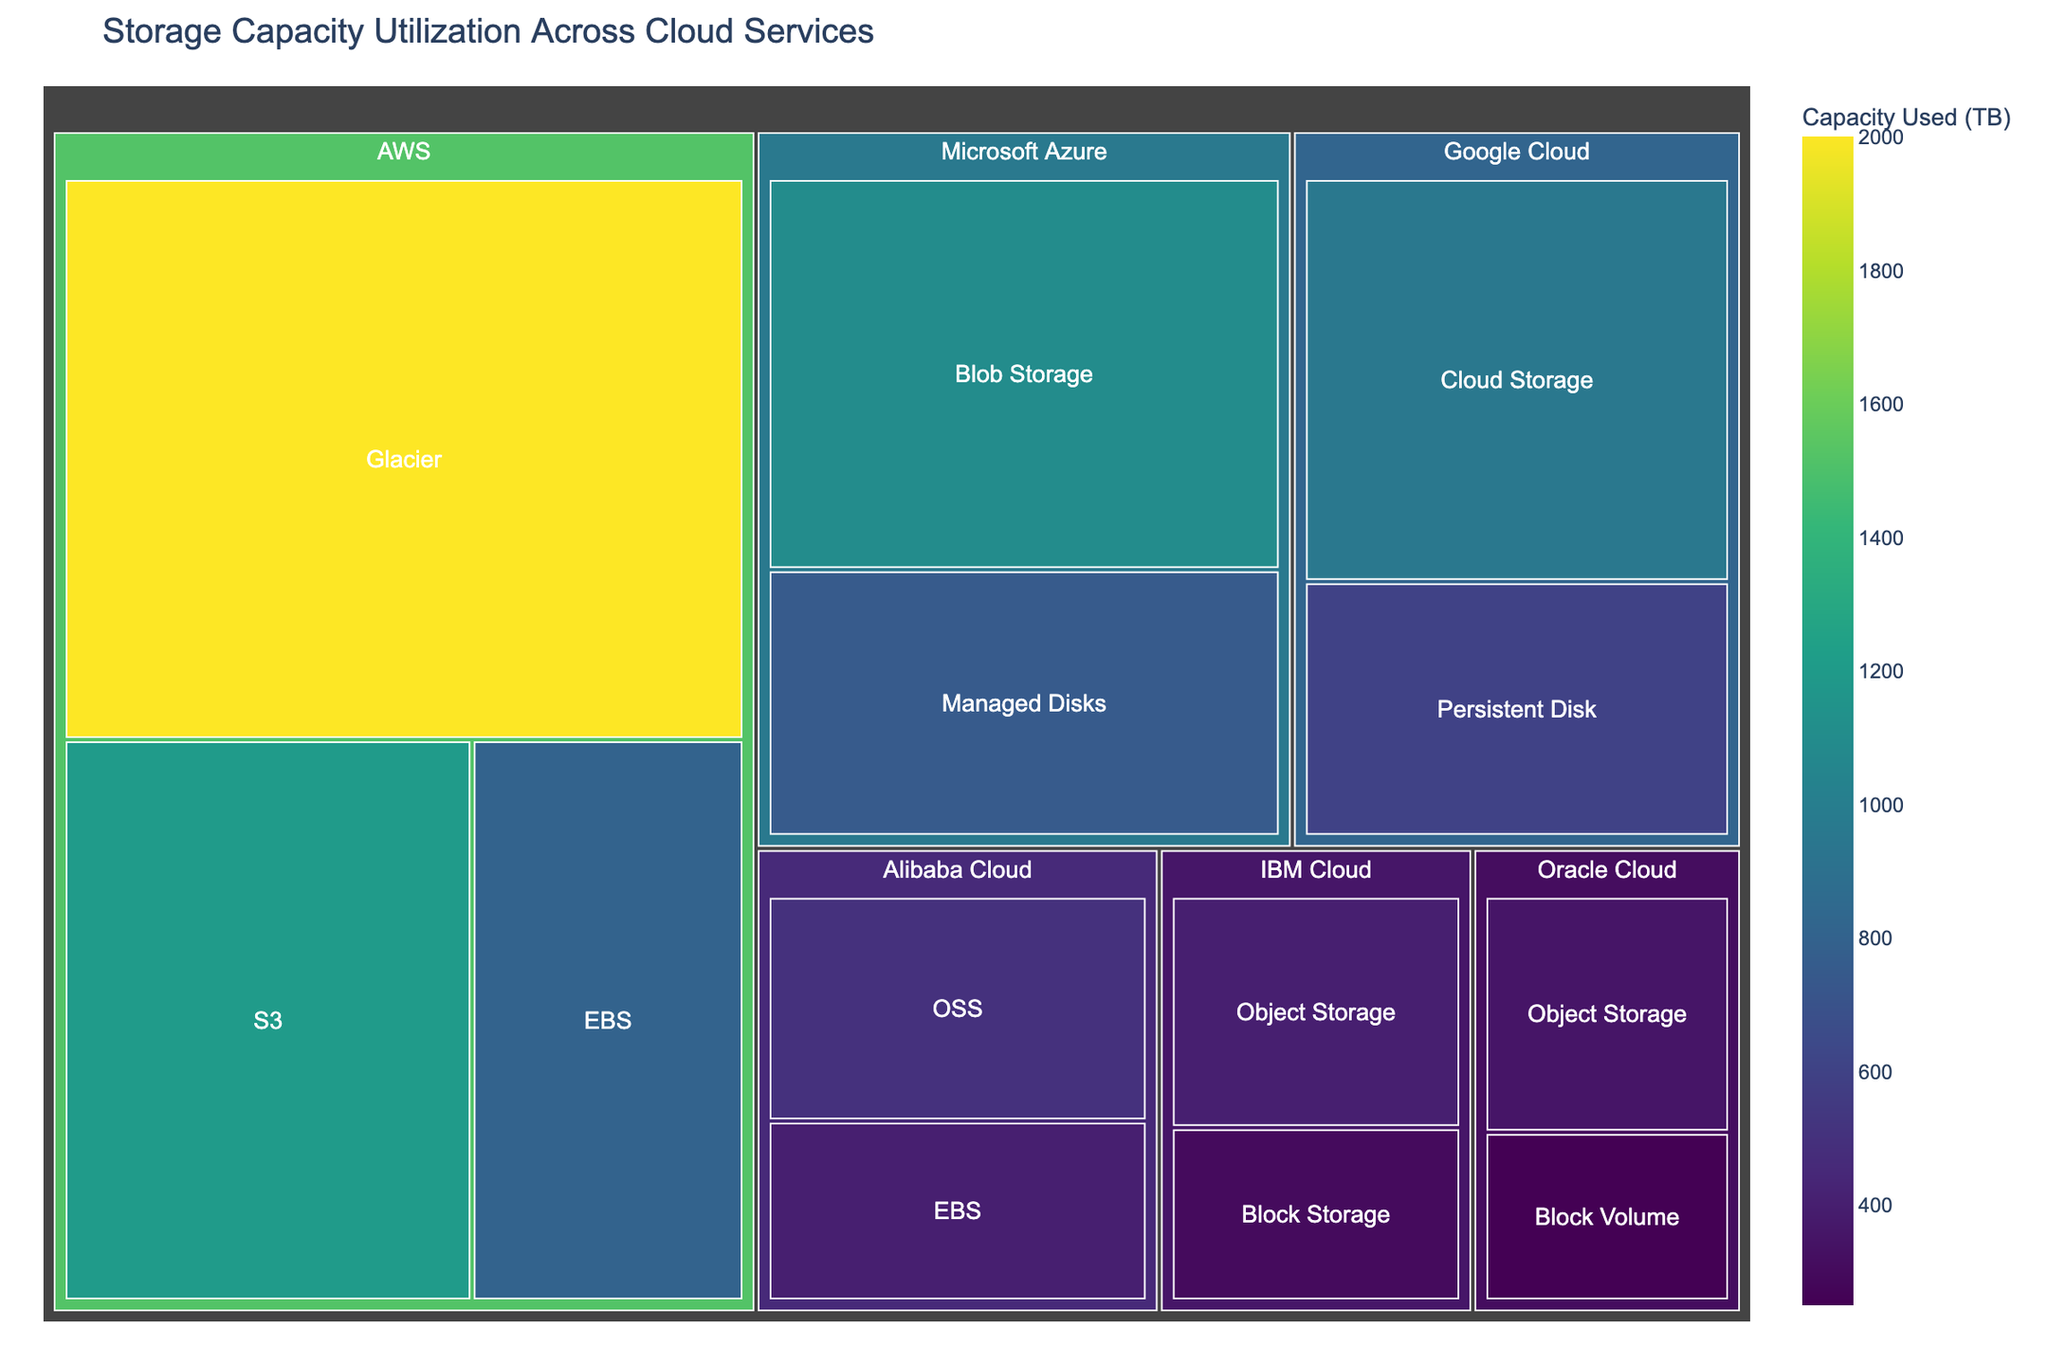Which cloud service has the highest storage capacity utilization? The cloud service is indicated by the top level of the Treemap. By looking at the size of the sections, we can see that AWS (Amazon Web Services) has the largest combined storage capacity.
Answer: AWS Which category in AWS has the highest utilization? Within the AWS section of the Treemap, compare the different categories by their sizes. The category with the largest block is Glacier with 2000 TB.
Answer: Glacier What is the combined storage capacity utilization for Google Cloud and IBM Cloud? Locate the Google Cloud and IBM Cloud sections on the Treemap. Sum the values for the different categories within each: Google Cloud (Cloud Storage: 950 TB, Persistent Disk: 600 TB) and IBM Cloud (Object Storage: 400 TB, Block Storage: 300 TB). The combined utilization is 950 + 600 + 400 + 300 = 2250 TB.
Answer: 2250 TB How does Microsoft Azure's Blob Storage compare to Alibaba Cloud's OSS in terms of storage capacity? Locate the sections for Microsoft Azure's Blob Storage and Alibaba Cloud's OSS on the Treemap. Blob Storage (1100 TB) is larger than OSS (500 TB).
Answer: Blob Storage is larger Which cloud service has the smallest storage capacity utilization? Identify the smallest section in the Treemap, which represents Oracle Cloud with a category of Block Volume at 250 TB.
Answer: Oracle Cloud What is the total storage capacity utilized across all cloud services? Add all the capacities from the Treemap to get the total: AWS (1200 + 800 + 2000), Google Cloud (950 + 600), Microsoft Azure (1100 + 750), IBM Cloud (400 + 300), Oracle Cloud (350 + 250), Alibaba Cloud (500 + 400). The total is (1200 + 800 + 2000 + 950 + 600 + 1100 + 750 + 400 + 300 + 350 + 250 + 500 + 400) = 9600 TB.
Answer: 9600 TB What is the average storage capacity utilization per category? Count the total number of categories in the Treemap. There are 13 categories. Sum the storage capacities (9600 TB) and divide by the number of categories: 9600 / 13 ≈ 738.5 TB.
Answer: 738.5 TB Which categories of storage have a utilization greater than 1000 TB? Examine the values within each section of the Treemap. The categories with utilization greater than 1000 TB are AWS Glacier (2000 TB), AWS S3 (1200 TB), and Microsoft Azure Blob Storage (1100 TB).
Answer: AWS Glacier, AWS S3, Microsoft Azure Blob Storage How much more storage capacity does AWS Glacier use compared to Google Cloud's Cloud Storage? Subtract the storage capacity of Google Cloud's Cloud Storage from AWS Glacier. AWS Glacier (2000 TB) and Google Cloud's Cloud Storage (950 TB). The difference is 2000 - 950 = 1050 TB.
Answer: 1050 TB 